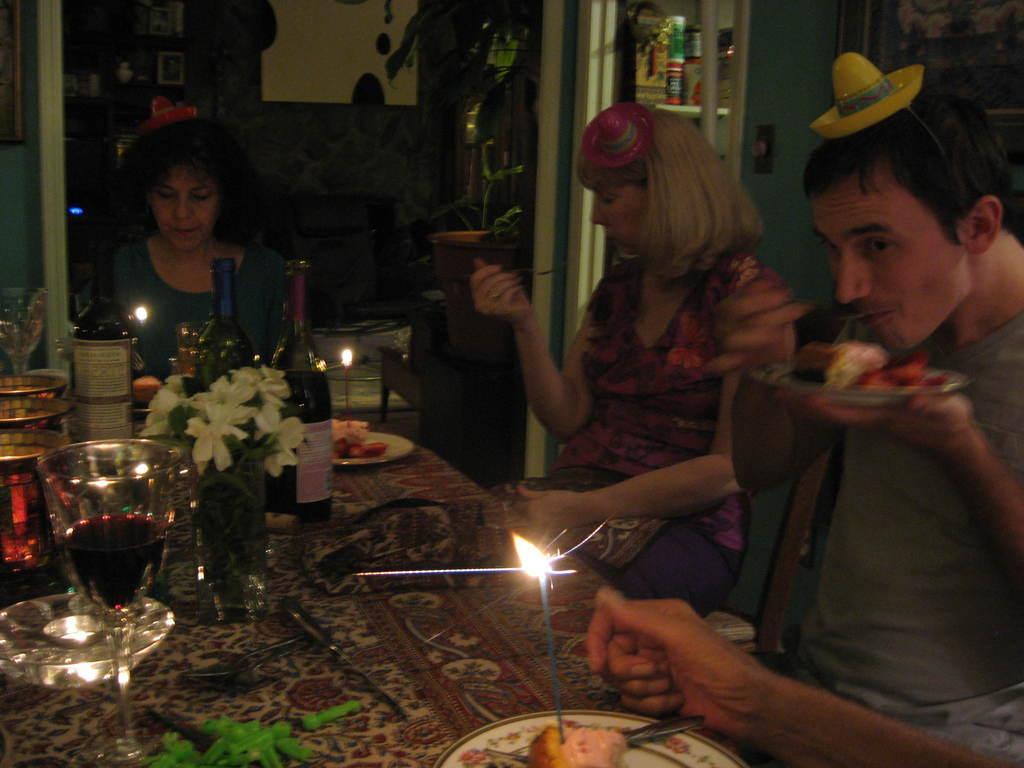How would you summarize this image in a sentence or two? There is a table. On that there are plates, glass, bowls, bottles, vase with flowers. On the plates there are food items. On the food item there is candle with light. There are some people sitting around the table. They are wearing small caps. In the background there is a wall. Also there is a pot with a plant and some other items in the background. 